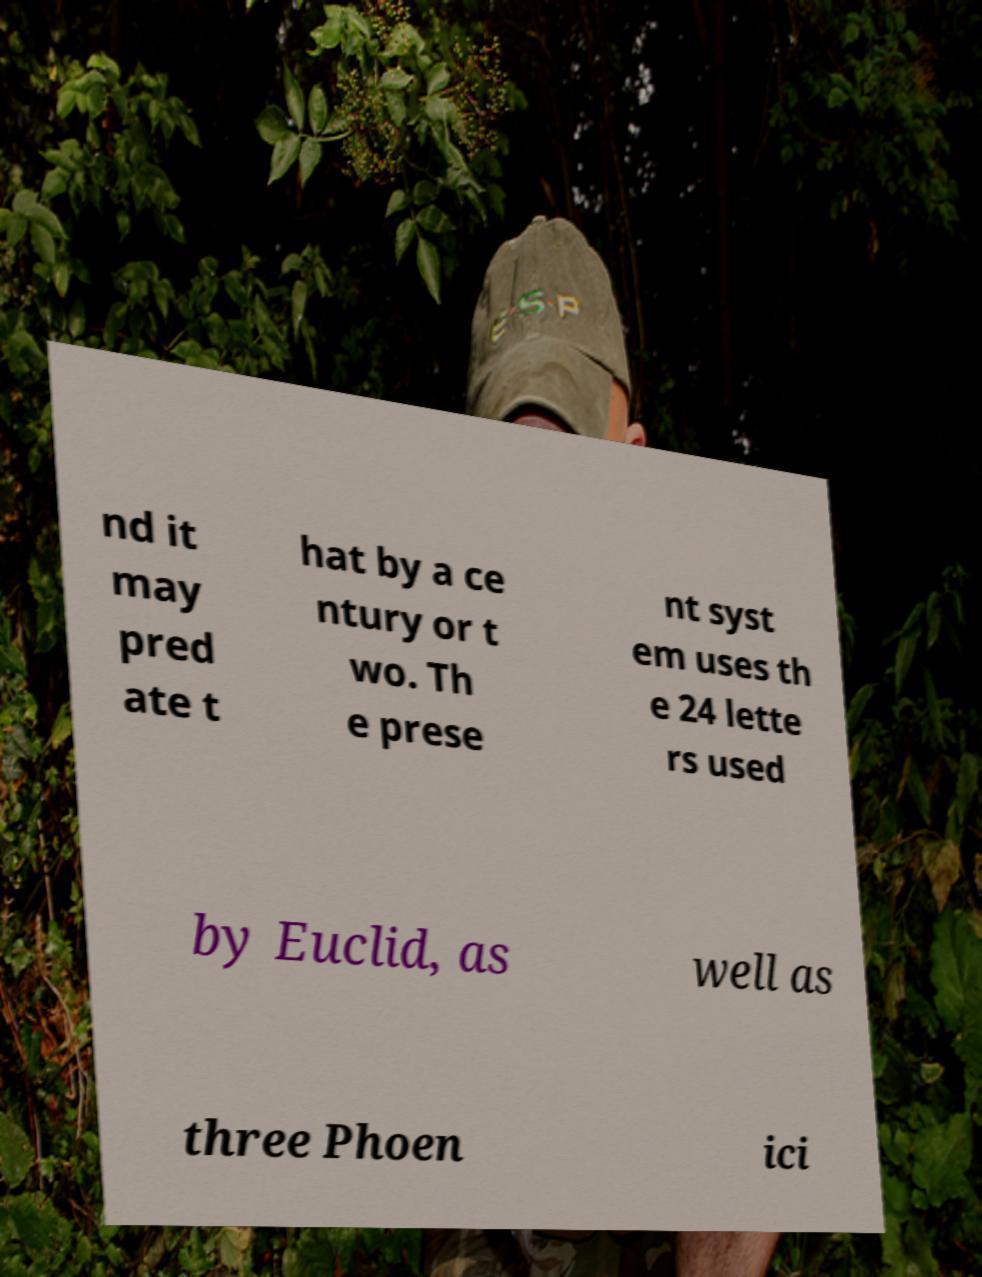Can you read and provide the text displayed in the image?This photo seems to have some interesting text. Can you extract and type it out for me? nd it may pred ate t hat by a ce ntury or t wo. Th e prese nt syst em uses th e 24 lette rs used by Euclid, as well as three Phoen ici 